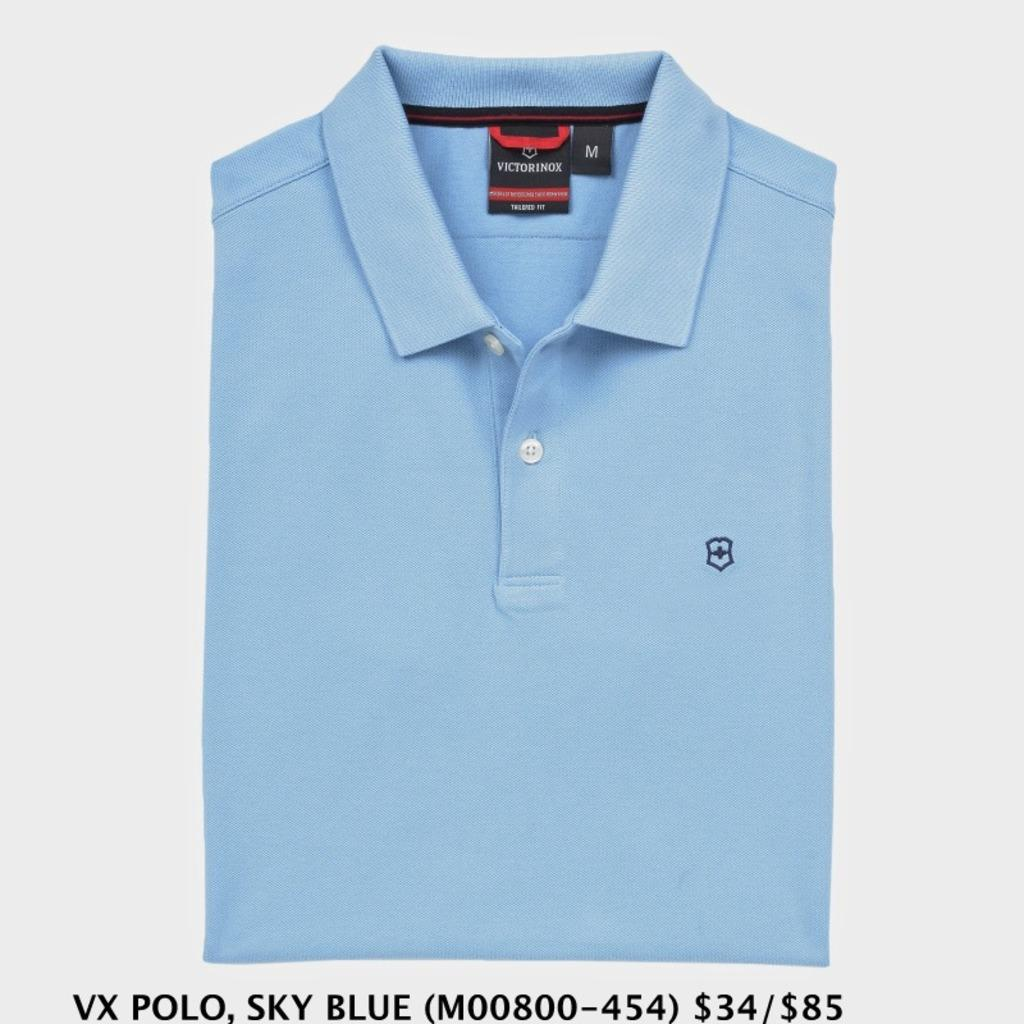<image>
Write a terse but informative summary of the picture. a folded blue shirt with tag that says victorinox 